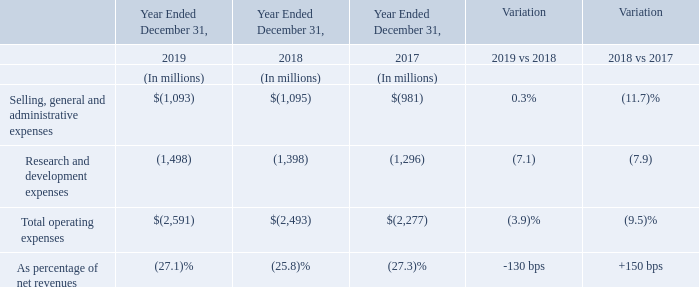The 2019 operating expenses increased 3.9% compared to the prior year, mainly due to salary dynamic, increased spending in certain R&D programs and higher share-based compensation cost, partially offset by favorable currency effects, net of hedging.
The 2018 operating expenses increased 9.5% compared to the prior year, mainly due to unfavorable currency effects, net of hedging, salary dynamic, increased R&D activities and higher costs of the share-based compensation plans.
The R&D expenses were net of research tax credits in France and Italy, which amounted to $126 million in 2019, $138 million in 2018 and $124 million in 2017.
In 2019, what were the reasons for increase in operating expenses? Due to salary dynamic, increased spending in certain r&d programs and higher share-based compensation cost, partially offset by favorable currency effects, net of hedging. In 2018, what were the reasons for increase in operating expenses? Due to unfavorable currency effects, net of hedging, salary dynamic, increased r&d activities and higher costs of the share-based compensation plans. How much did the R&D expenses amounted for in 2019, 2018 and 2017? The r&d expenses were net of research tax credits in france and italy, which amounted to $126 million in 2019, $138 million in 2018 and $124 million in 2017. What is the average Selling, general and administrative expenses?
Answer scale should be: million. (1,093+1,095+981) / 3
Answer: 1056.33. What is the average Research and development expenses?
Answer scale should be: million. (1,498+1,398+1,296) / 3
Answer: 1397.33. What is the increase/ (decrease) in total operating expenses as percentage of net revenues from 2017 to 2019?
Answer scale should be: percent. 27.1-27.3
Answer: -0.2. 